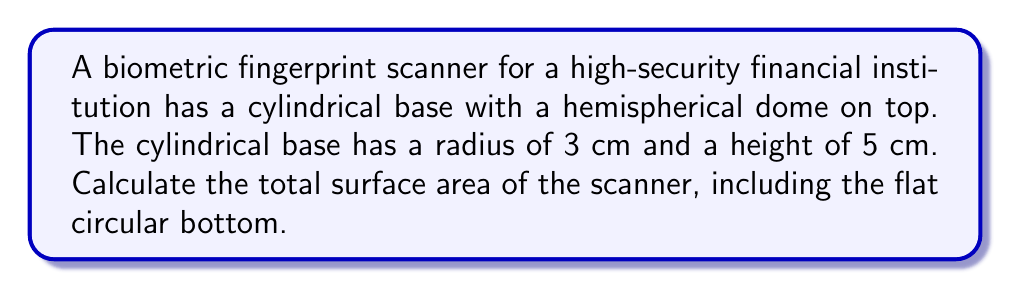What is the answer to this math problem? To find the total surface area, we need to calculate and sum the areas of:
1. The cylindrical surface
2. The hemispherical dome
3. The flat circular bottom

Step 1: Cylindrical surface area
$$ A_{cylinder} = 2\pi rh $$
where $r$ is the radius and $h$ is the height.
$$ A_{cylinder} = 2\pi(3)(5) = 30\pi \text{ cm}^2 $$

Step 2: Hemispherical surface area
$$ A_{hemisphere} = 2\pi r^2 $$
$$ A_{hemisphere} = 2\pi(3^2) = 18\pi \text{ cm}^2 $$

Step 3: Circular bottom area
$$ A_{circle} = \pi r^2 $$
$$ A_{circle} = \pi(3^2) = 9\pi \text{ cm}^2 $$

Step 4: Total surface area
$$ A_{total} = A_{cylinder} + A_{hemisphere} + A_{circle} $$
$$ A_{total} = 30\pi + 18\pi + 9\pi = 57\pi \text{ cm}^2 $$
Answer: $57\pi \text{ cm}^2$ 